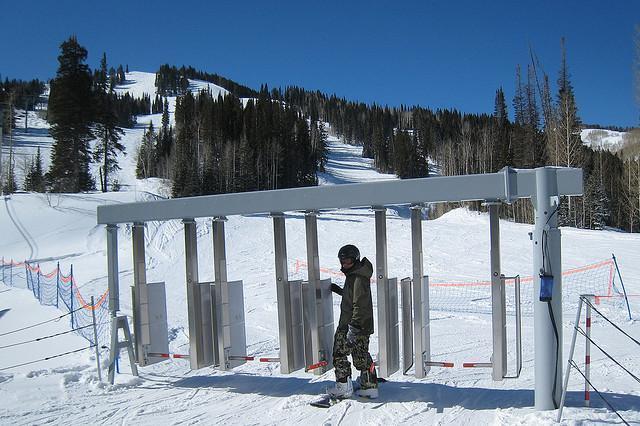How many cats have their eyes closed?
Give a very brief answer. 0. 